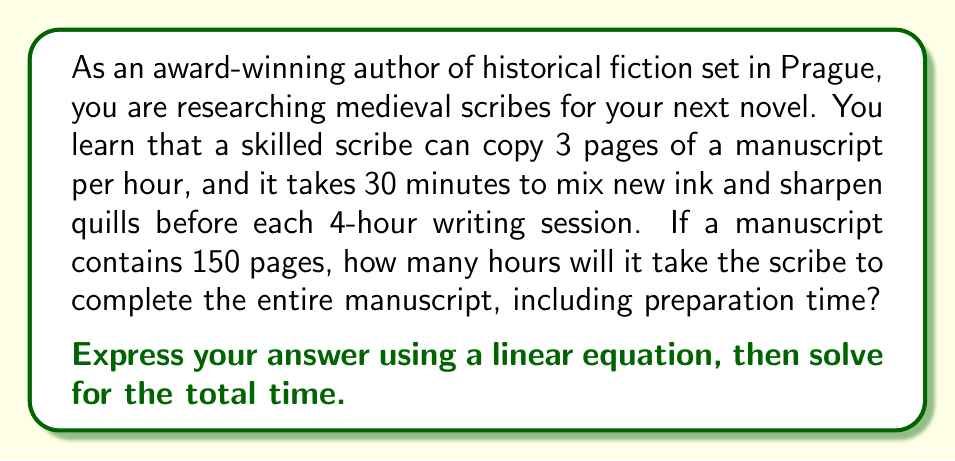Teach me how to tackle this problem. Let's approach this step-by-step:

1) First, let's define our variables:
   $x$ = number of 4-hour writing sessions
   $y$ = total time in hours

2) We can express the total time as a linear equation:
   $y = 4.5x$
   (4 hours of writing + 0.5 hours of preparation per session)

3) Now, we need to determine how many sessions are needed to complete 150 pages:
   Pages per session = 3 pages/hour × 4 hours = 12 pages
   Number of sessions needed = $\frac{150 \text{ pages}}{12 \text{ pages/session}} = 12.5$ sessions

4) Since we can't have a partial session, we round up to 13 sessions.

5) Now we can plug this into our equation:
   $y = 4.5x$
   $y = 4.5(13)$
   $y = 58.5$

Therefore, it will take 58.5 hours to complete the manuscript.

To verify:
13 sessions × 4 hours writing = 52 hours writing
13 sessions × 0.5 hours preparation = 6.5 hours preparation
52 + 6.5 = 58.5 hours total

This covers exactly 156 pages (13 × 12), which is sufficient for the 150-page manuscript.
Answer: The scribe will require 58.5 hours to complete the 150-page manuscript, including preparation time. This can be expressed by the linear equation $y = 4.5x$, where $x = 13$ (number of sessions) and $y = 58.5$ (total hours). 